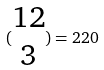<formula> <loc_0><loc_0><loc_500><loc_500>( \begin{matrix} 1 2 \\ 3 \end{matrix} ) = 2 2 0</formula> 